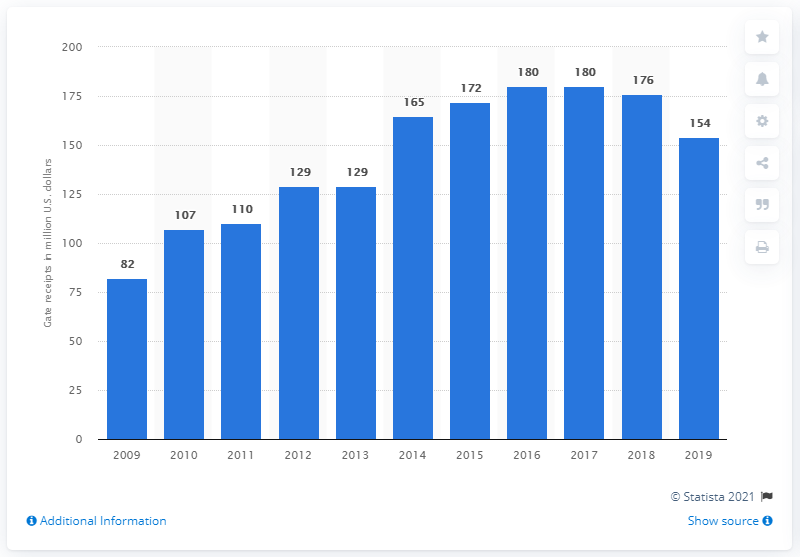Draw attention to some important aspects in this diagram. In 2009, the gate receipts of the San Francisco Giants were 82. In 2014, the gate receipts of the San Francisco Giants were 165 million dollars. In 2019, the gate receipts of the San Francisco Giants totaled 154 million dollars. 